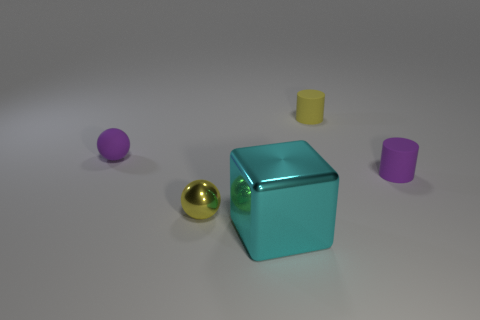Add 1 spheres. How many objects exist? 6 Subtract all blocks. How many objects are left? 4 Subtract all purple spheres. Subtract all small matte cylinders. How many objects are left? 2 Add 4 yellow matte cylinders. How many yellow matte cylinders are left? 5 Add 5 purple balls. How many purple balls exist? 6 Subtract 0 gray cylinders. How many objects are left? 5 